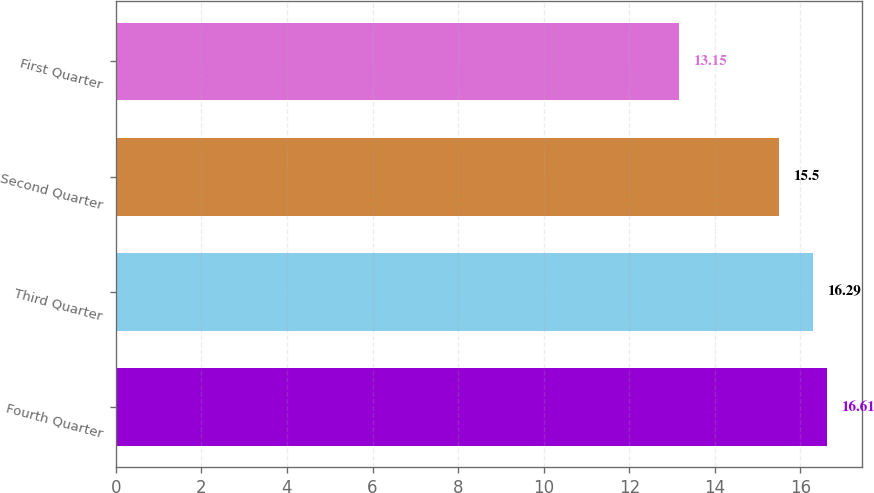<chart> <loc_0><loc_0><loc_500><loc_500><bar_chart><fcel>Fourth Quarter<fcel>Third Quarter<fcel>Second Quarter<fcel>First Quarter<nl><fcel>16.61<fcel>16.29<fcel>15.5<fcel>13.15<nl></chart> 